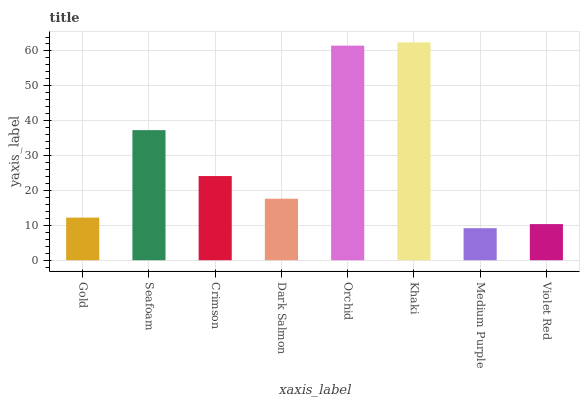Is Seafoam the minimum?
Answer yes or no. No. Is Seafoam the maximum?
Answer yes or no. No. Is Seafoam greater than Gold?
Answer yes or no. Yes. Is Gold less than Seafoam?
Answer yes or no. Yes. Is Gold greater than Seafoam?
Answer yes or no. No. Is Seafoam less than Gold?
Answer yes or no. No. Is Crimson the high median?
Answer yes or no. Yes. Is Dark Salmon the low median?
Answer yes or no. Yes. Is Gold the high median?
Answer yes or no. No. Is Orchid the low median?
Answer yes or no. No. 